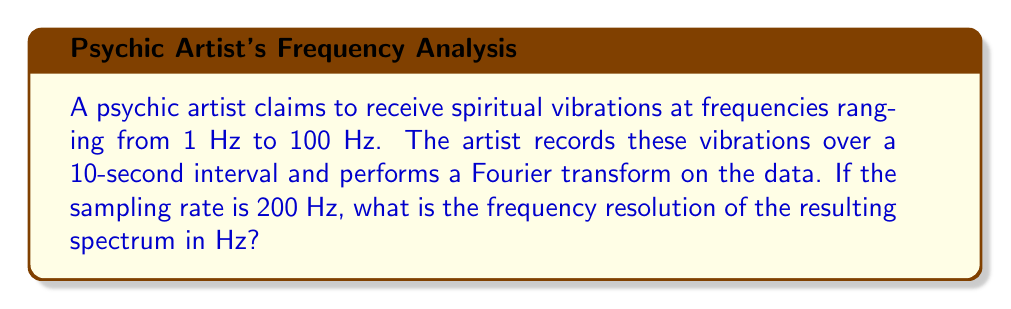Teach me how to tackle this problem. To solve this problem, we need to understand the relationship between sampling time, number of samples, and frequency resolution in Fourier analysis.

Step 1: Determine the total number of samples.
Sample rate = 200 Hz
Recording time = 10 seconds
Total samples = Sample rate × Recording time
$N = 200 \text{ Hz} \times 10 \text{ s} = 2000 \text{ samples}$

Step 2: Calculate the frequency resolution.
The frequency resolution (Δf) is given by the reciprocal of the total recording time (T):

$$\Delta f = \frac{1}{T}$$

Where T is the total recording time in seconds.

$\Delta f = \frac{1}{10 \text{ s}} = 0.1 \text{ Hz}$

Therefore, the frequency resolution of the spectrum is 0.1 Hz.
Answer: 0.1 Hz 